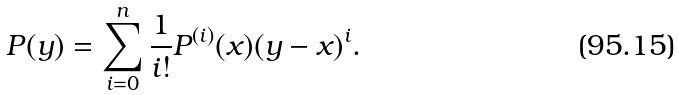Convert formula to latex. <formula><loc_0><loc_0><loc_500><loc_500>P ( y ) = \sum _ { i = 0 } ^ { n } \frac { 1 } { i ! } P ^ { ( i ) } ( x ) ( y - x ) ^ { i } .</formula> 